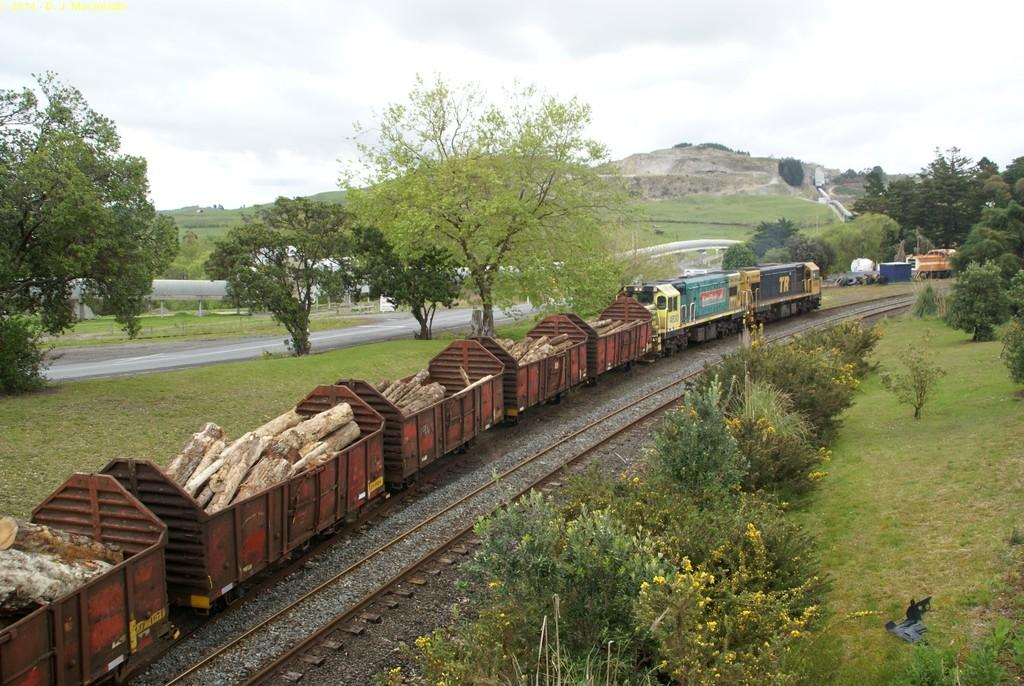What type of train is in the image? There is a goods train in the image. What is the train doing in the image? The train is moving on a railway track. What is the train carrying? The train is carrying wooden logs. What can be seen in the background of the image? There are trees and a hill in the background of the image, and the sky is also visible. What type of mitten is being used to distribute marbles in the image? There is no mitten or marbles present in the image; it features a goods train carrying wooden logs. 